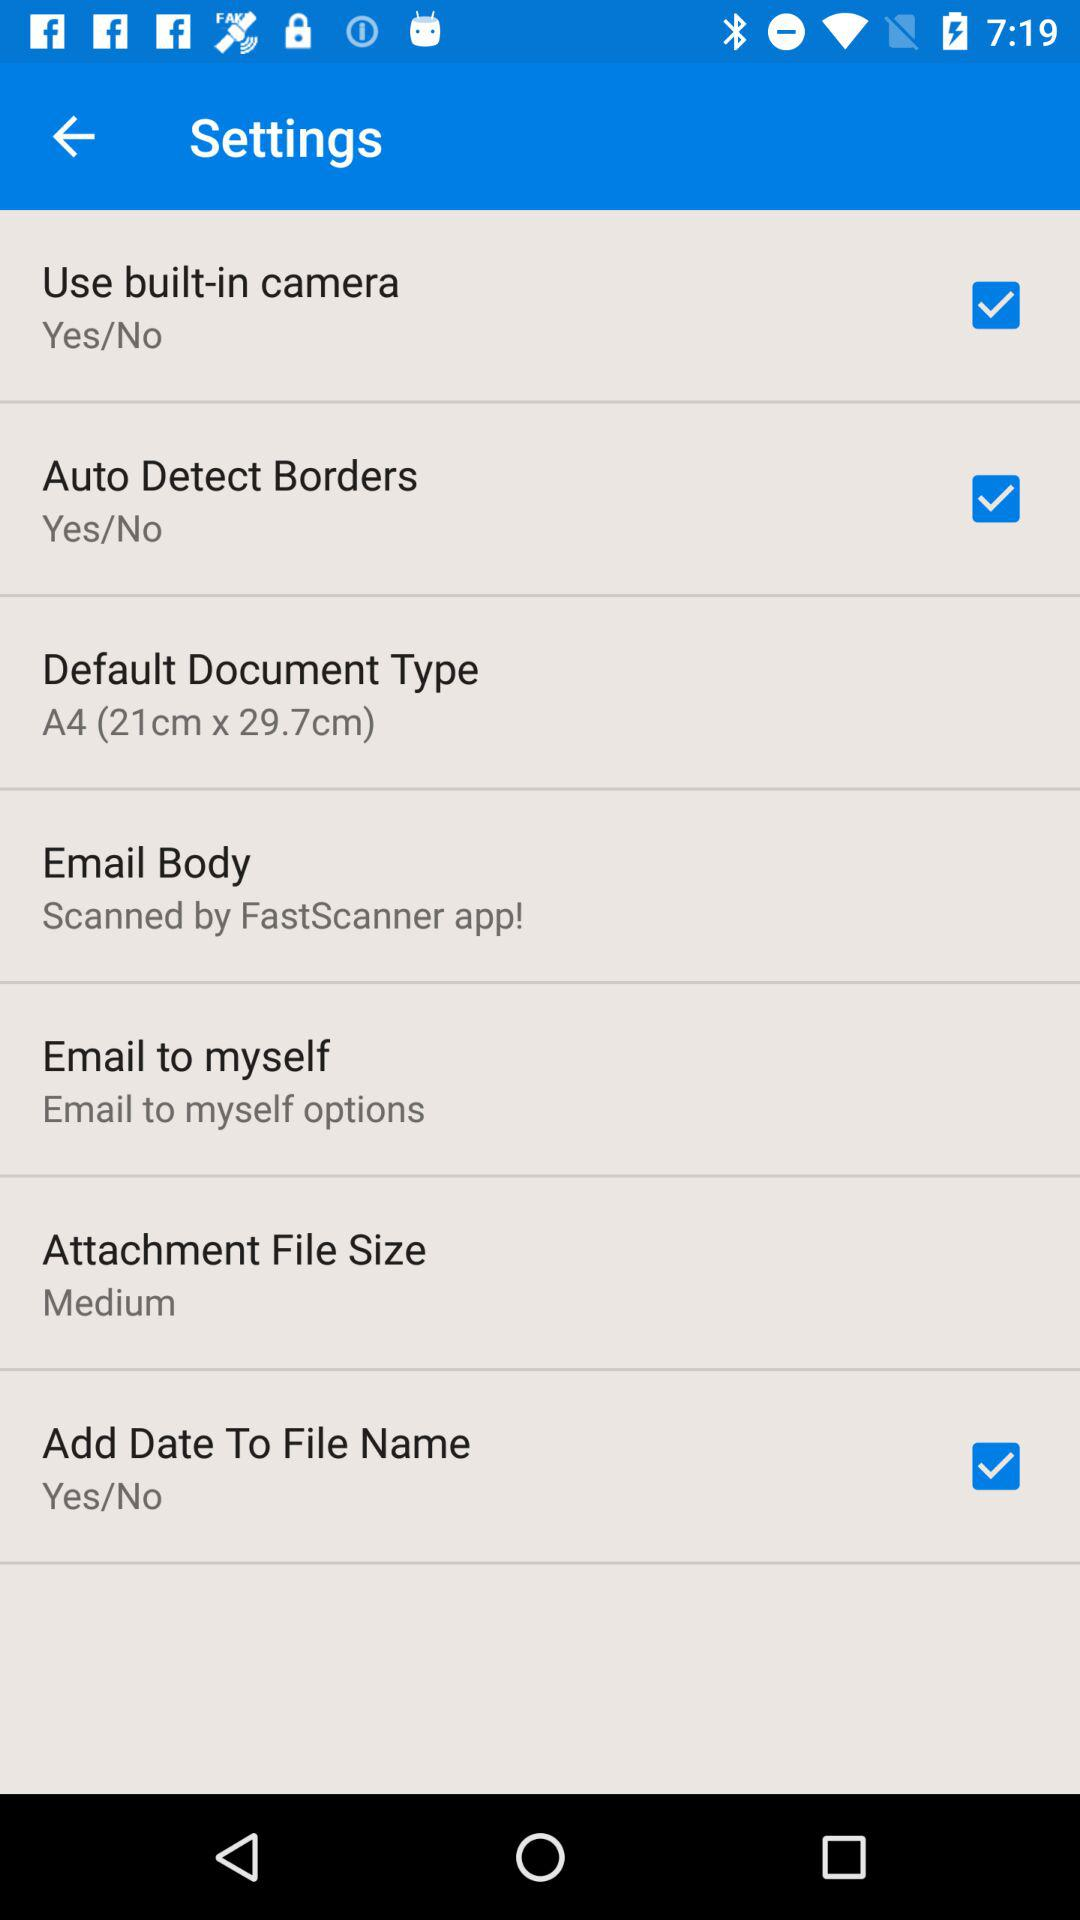What is the default document type? The default document type is "A4 (21cm x 29.7cm)". 